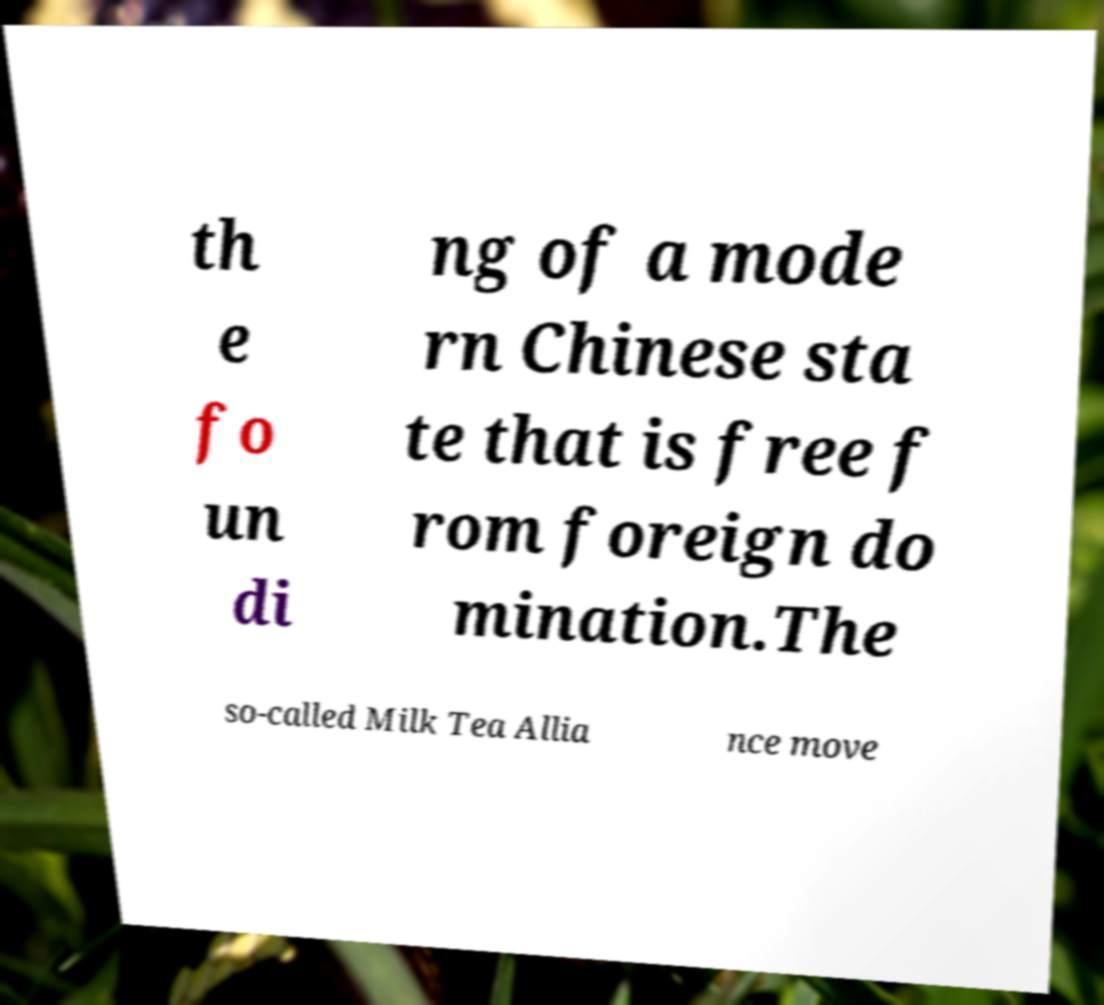Can you read and provide the text displayed in the image?This photo seems to have some interesting text. Can you extract and type it out for me? th e fo un di ng of a mode rn Chinese sta te that is free f rom foreign do mination.The so-called Milk Tea Allia nce move 